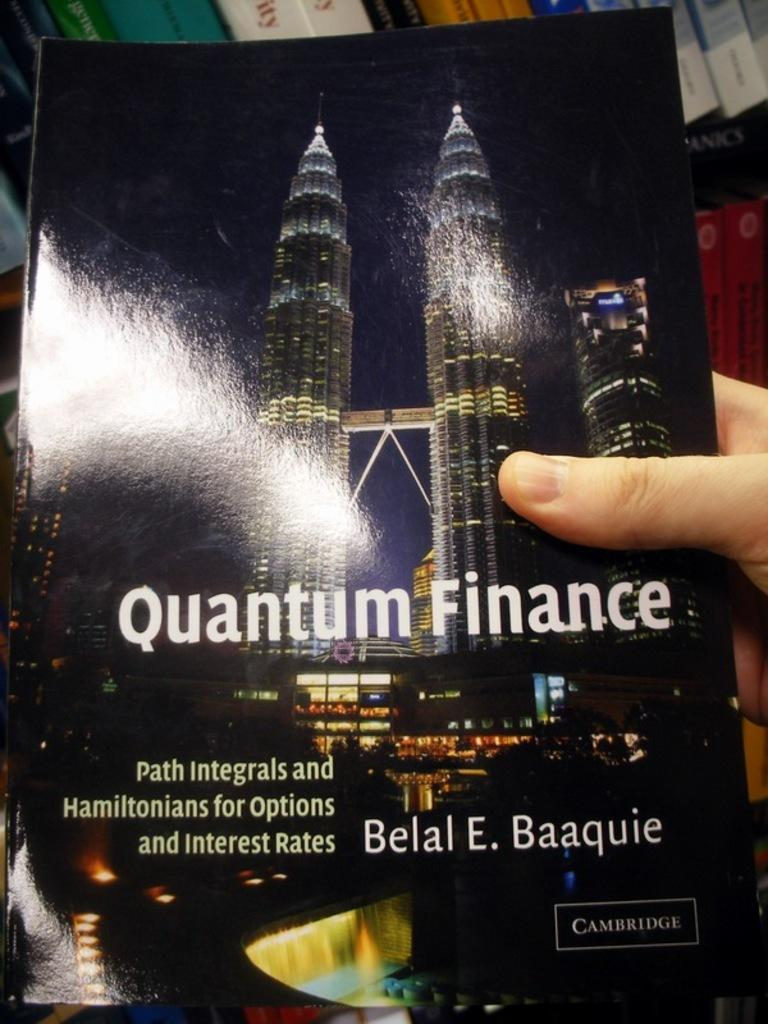<image>
Render a clear and concise summary of the photo. A hand is holding a poster with a skyline and the text quantum finance on the center of it. 